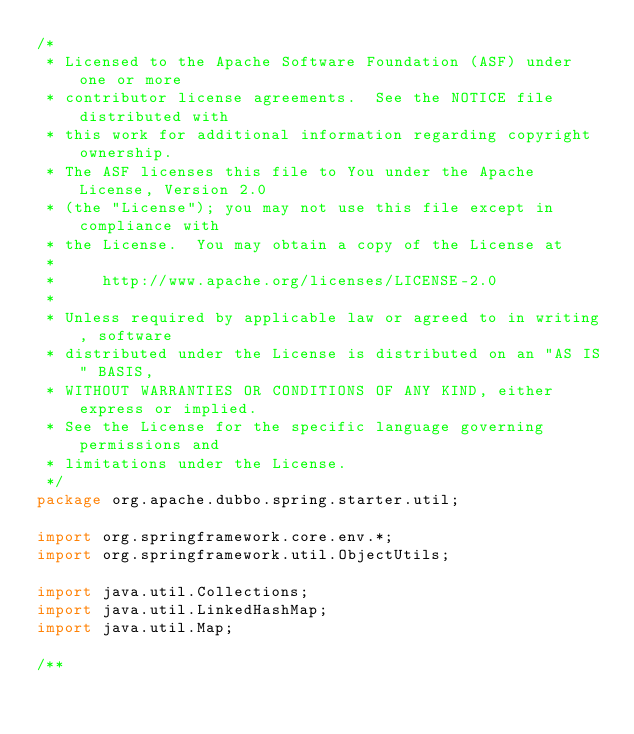<code> <loc_0><loc_0><loc_500><loc_500><_Java_>/*
 * Licensed to the Apache Software Foundation (ASF) under one or more
 * contributor license agreements.  See the NOTICE file distributed with
 * this work for additional information regarding copyright ownership.
 * The ASF licenses this file to You under the Apache License, Version 2.0
 * (the "License"); you may not use this file except in compliance with
 * the License.  You may obtain a copy of the License at
 *
 *     http://www.apache.org/licenses/LICENSE-2.0
 *
 * Unless required by applicable law or agreed to in writing, software
 * distributed under the License is distributed on an "AS IS" BASIS,
 * WITHOUT WARRANTIES OR CONDITIONS OF ANY KIND, either express or implied.
 * See the License for the specific language governing permissions and
 * limitations under the License.
 */
package org.apache.dubbo.spring.starter.util;

import org.springframework.core.env.*;
import org.springframework.util.ObjectUtils;

import java.util.Collections;
import java.util.LinkedHashMap;
import java.util.Map;

/**</code> 